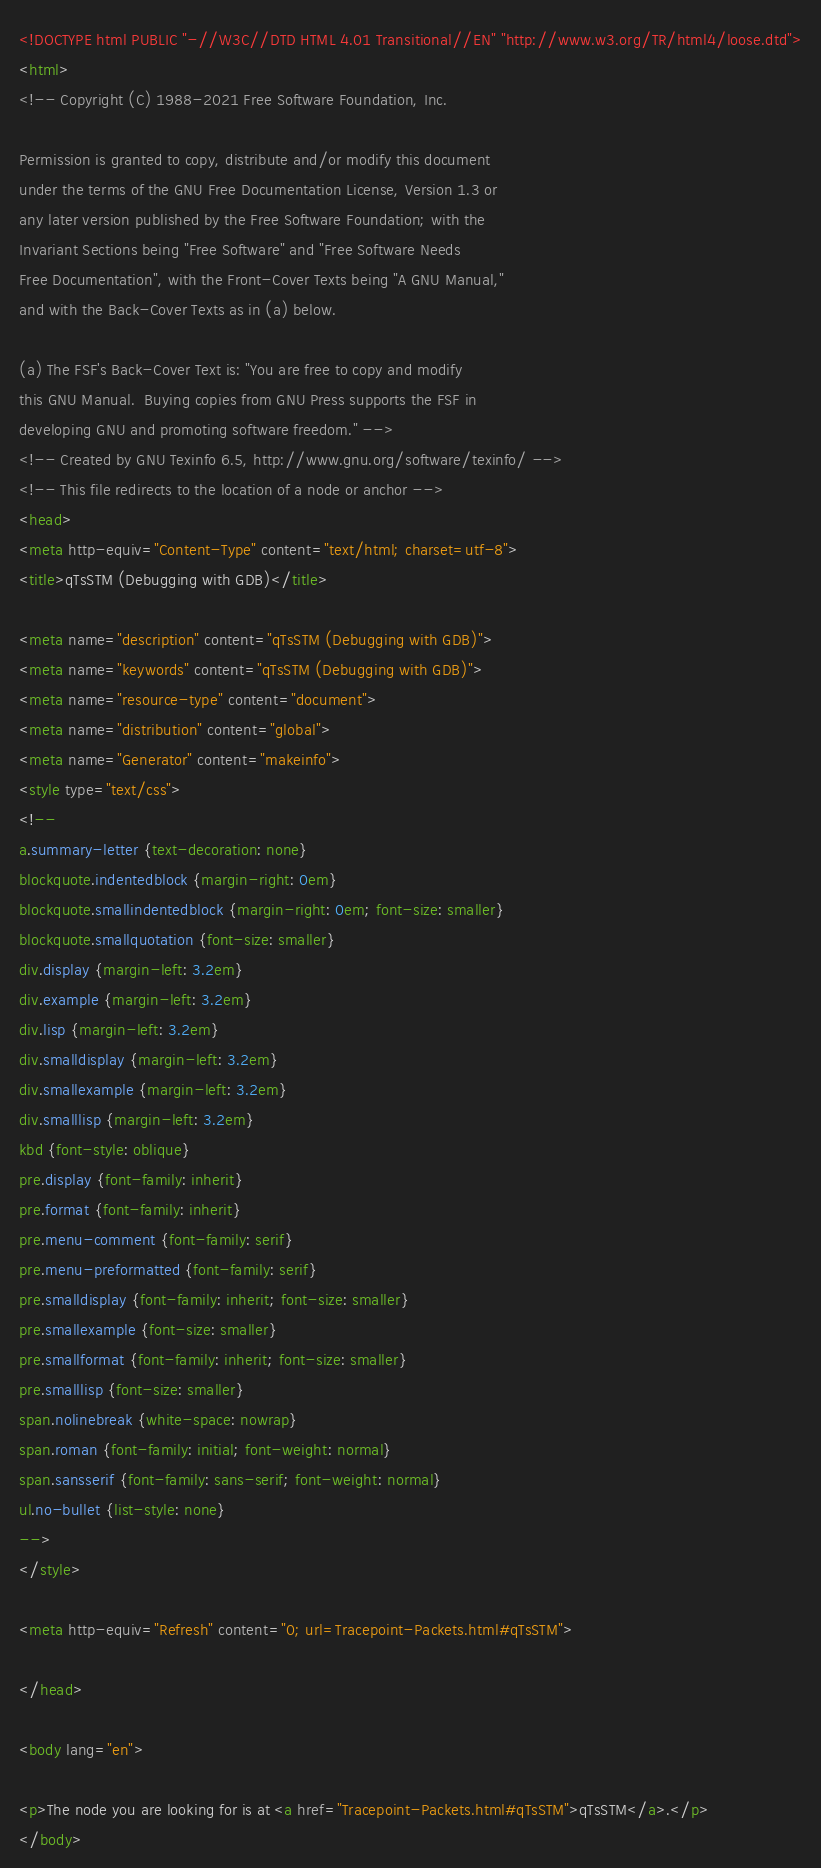Convert code to text. <code><loc_0><loc_0><loc_500><loc_500><_HTML_><!DOCTYPE html PUBLIC "-//W3C//DTD HTML 4.01 Transitional//EN" "http://www.w3.org/TR/html4/loose.dtd">
<html>
<!-- Copyright (C) 1988-2021 Free Software Foundation, Inc.

Permission is granted to copy, distribute and/or modify this document
under the terms of the GNU Free Documentation License, Version 1.3 or
any later version published by the Free Software Foundation; with the
Invariant Sections being "Free Software" and "Free Software Needs
Free Documentation", with the Front-Cover Texts being "A GNU Manual,"
and with the Back-Cover Texts as in (a) below.

(a) The FSF's Back-Cover Text is: "You are free to copy and modify
this GNU Manual.  Buying copies from GNU Press supports the FSF in
developing GNU and promoting software freedom." -->
<!-- Created by GNU Texinfo 6.5, http://www.gnu.org/software/texinfo/ -->
<!-- This file redirects to the location of a node or anchor -->
<head>
<meta http-equiv="Content-Type" content="text/html; charset=utf-8">
<title>qTsSTM (Debugging with GDB)</title>

<meta name="description" content="qTsSTM (Debugging with GDB)">
<meta name="keywords" content="qTsSTM (Debugging with GDB)">
<meta name="resource-type" content="document">
<meta name="distribution" content="global">
<meta name="Generator" content="makeinfo">
<style type="text/css">
<!--
a.summary-letter {text-decoration: none}
blockquote.indentedblock {margin-right: 0em}
blockquote.smallindentedblock {margin-right: 0em; font-size: smaller}
blockquote.smallquotation {font-size: smaller}
div.display {margin-left: 3.2em}
div.example {margin-left: 3.2em}
div.lisp {margin-left: 3.2em}
div.smalldisplay {margin-left: 3.2em}
div.smallexample {margin-left: 3.2em}
div.smalllisp {margin-left: 3.2em}
kbd {font-style: oblique}
pre.display {font-family: inherit}
pre.format {font-family: inherit}
pre.menu-comment {font-family: serif}
pre.menu-preformatted {font-family: serif}
pre.smalldisplay {font-family: inherit; font-size: smaller}
pre.smallexample {font-size: smaller}
pre.smallformat {font-family: inherit; font-size: smaller}
pre.smalllisp {font-size: smaller}
span.nolinebreak {white-space: nowrap}
span.roman {font-family: initial; font-weight: normal}
span.sansserif {font-family: sans-serif; font-weight: normal}
ul.no-bullet {list-style: none}
-->
</style>

<meta http-equiv="Refresh" content="0; url=Tracepoint-Packets.html#qTsSTM">

</head>

<body lang="en">

<p>The node you are looking for is at <a href="Tracepoint-Packets.html#qTsSTM">qTsSTM</a>.</p>
</body>
</code> 